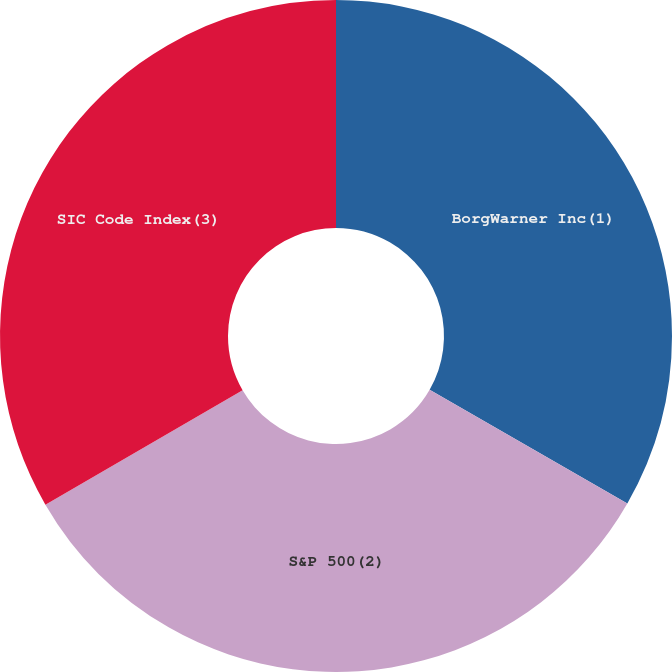<chart> <loc_0><loc_0><loc_500><loc_500><pie_chart><fcel>BorgWarner Inc(1)<fcel>S&P 500(2)<fcel>SIC Code Index(3)<nl><fcel>33.3%<fcel>33.33%<fcel>33.37%<nl></chart> 